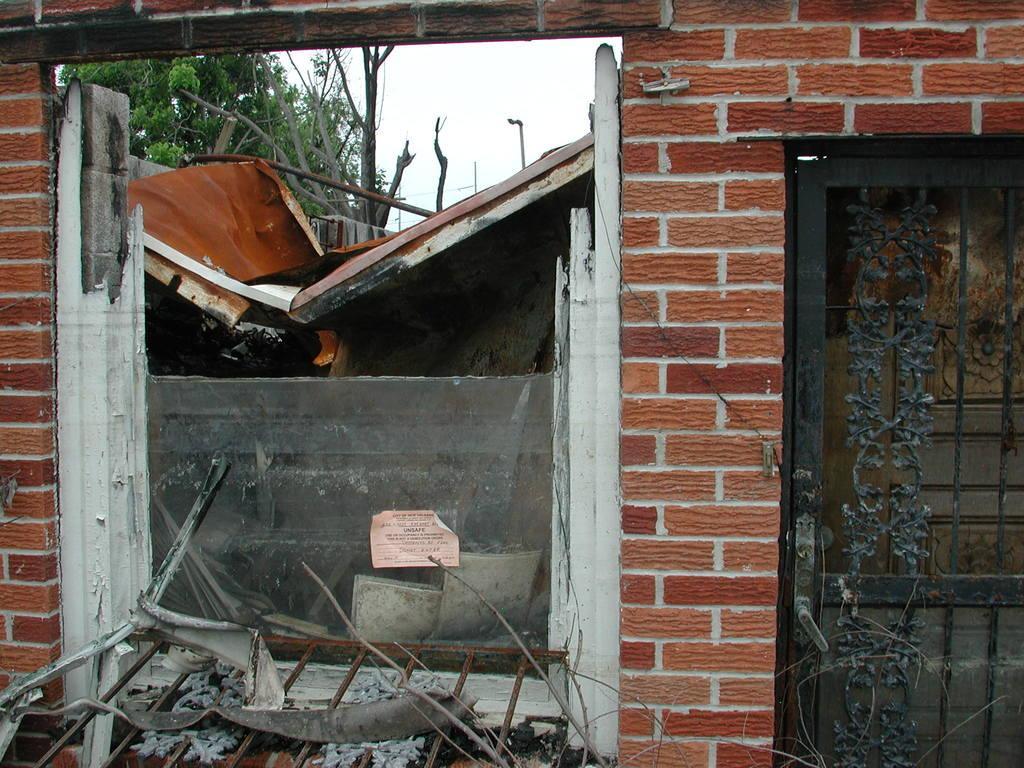Describe this image in one or two sentences. In the background we can see the sky, trees, poles. In this picture we can see grille, objects, paper with some information, wall and few objects. On the right side of the picture we can see a gate. 